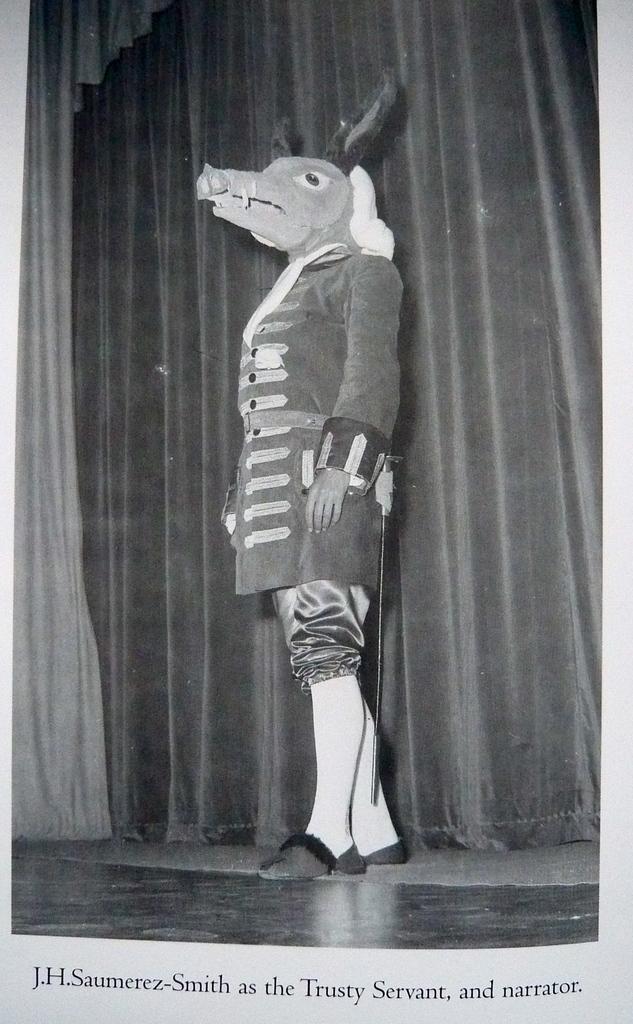Please provide a concise description of this image. This is a stage. On that there is a person wearing a mask of a animal. In the back there is curtain. And there is something written on the down. This is a black and white picture. 